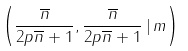Convert formula to latex. <formula><loc_0><loc_0><loc_500><loc_500>\left ( \frac { \overline { n } } { 2 p \overline { n } + 1 } , \frac { \overline { n } } { 2 p \overline { n } + 1 } \, | \, m \right )</formula> 